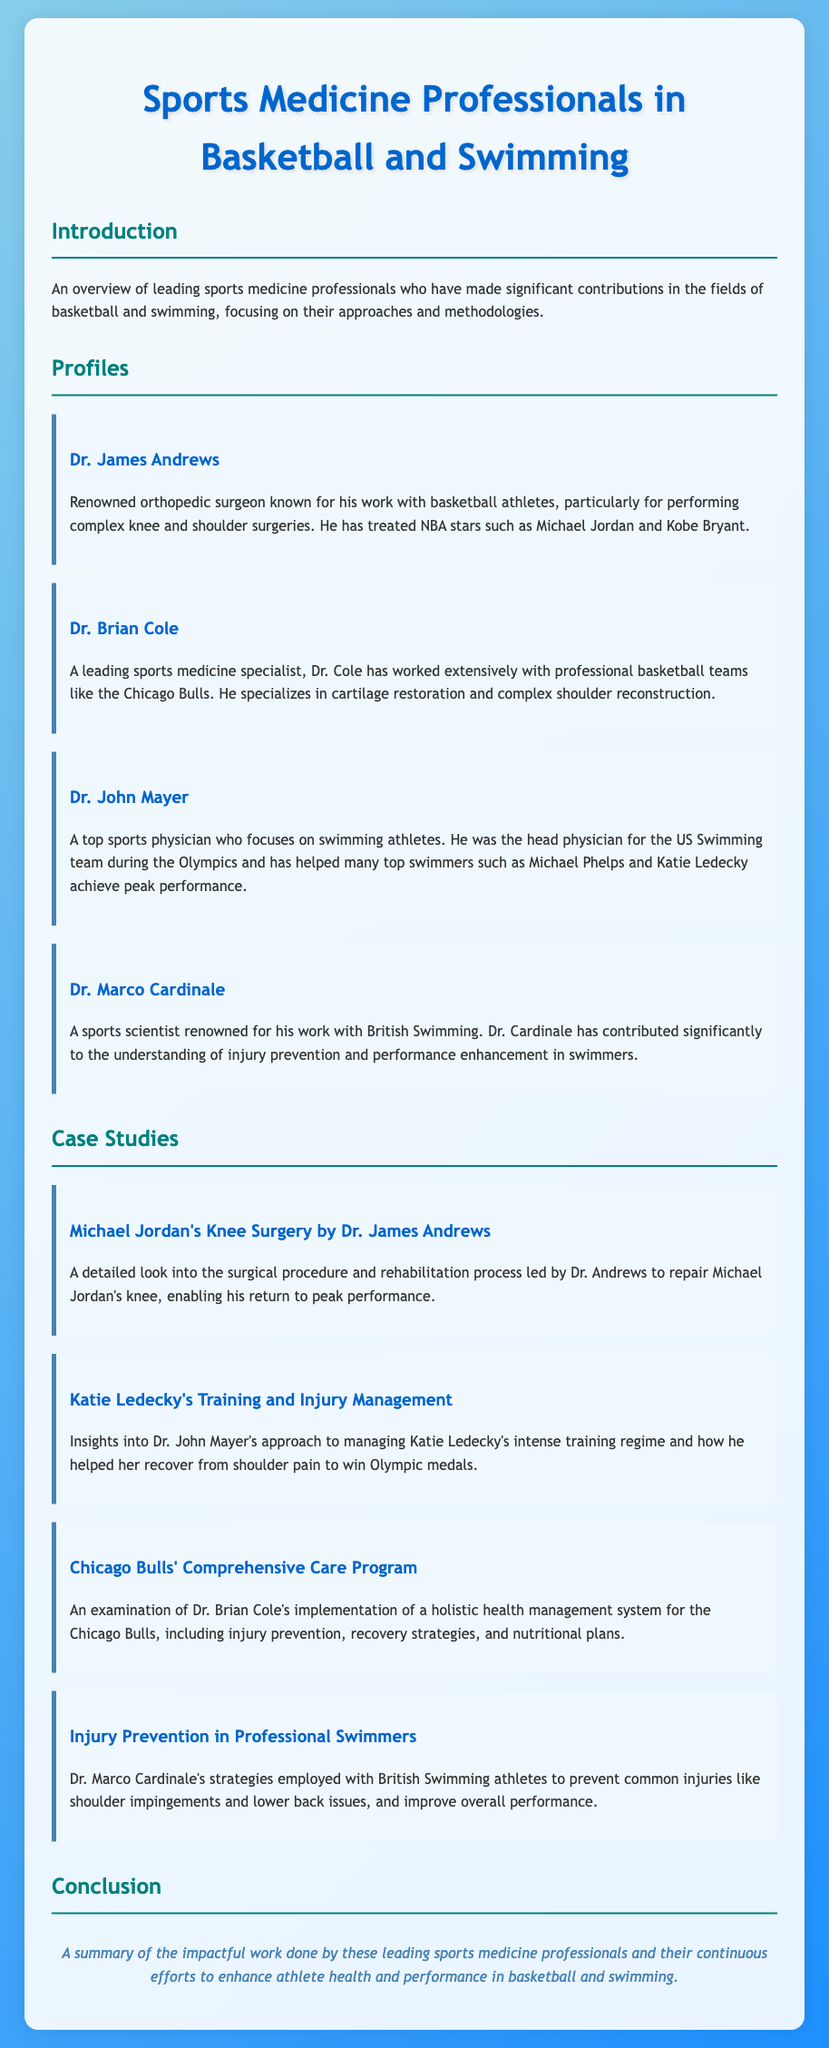What is the name of the orthopedic surgeon known for his work with basketball athletes? The document mentions Dr. James Andrews as the renowned orthopedic surgeon.
Answer: Dr. James Andrews Who was the head physician for the US Swimming team during the Olympics? Dr. John Mayer is identified as the head physician for the US Swimming team during the Olympics.
Answer: Dr. John Mayer Which professional swimmer did Dr. John Mayer help achieve peak performance? The document states that Dr. John Mayer helped Michael Phelps and Katie Ledecky.
Answer: Michael Phelps and Katie Ledecky What is Dr. Brian Cole known for in sports medicine? The document indicates that Dr. Brian Cole specializes in cartilage restoration and complex shoulder reconstruction.
Answer: Cartilage restoration and complex shoulder reconstruction How many case studies are presented in the document? The document lists four case studies related to different athletes and treatments.
Answer: Four What was the focus of Dr. Marco Cardinale's work with British Swimming? The document states that he contributed significantly to injury prevention and performance enhancement in swimmers.
Answer: Injury prevention and performance enhancement What notable surgery did Dr. James Andrews perform on Michael Jordan? The document refers to the surgical procedure that repaired Michael Jordan's knee.
Answer: Knee surgery What is one key strategy employed by Dr. Marco Cardinale? The document notes that Dr. Cardinale's strategies included preventing common injuries like shoulder impingements.
Answer: Preventing common injuries like shoulder impingements 